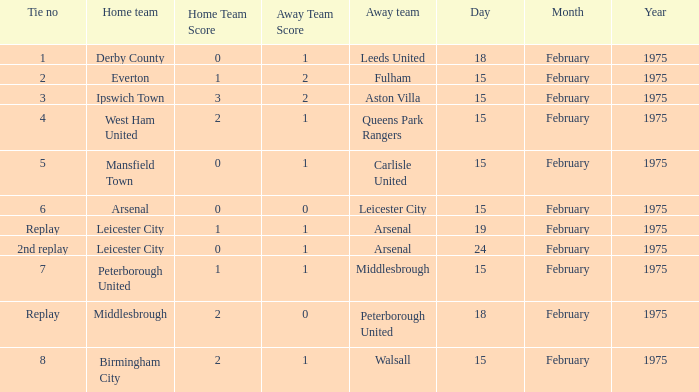What was the tie number when peterborough united was the away team? Replay. 